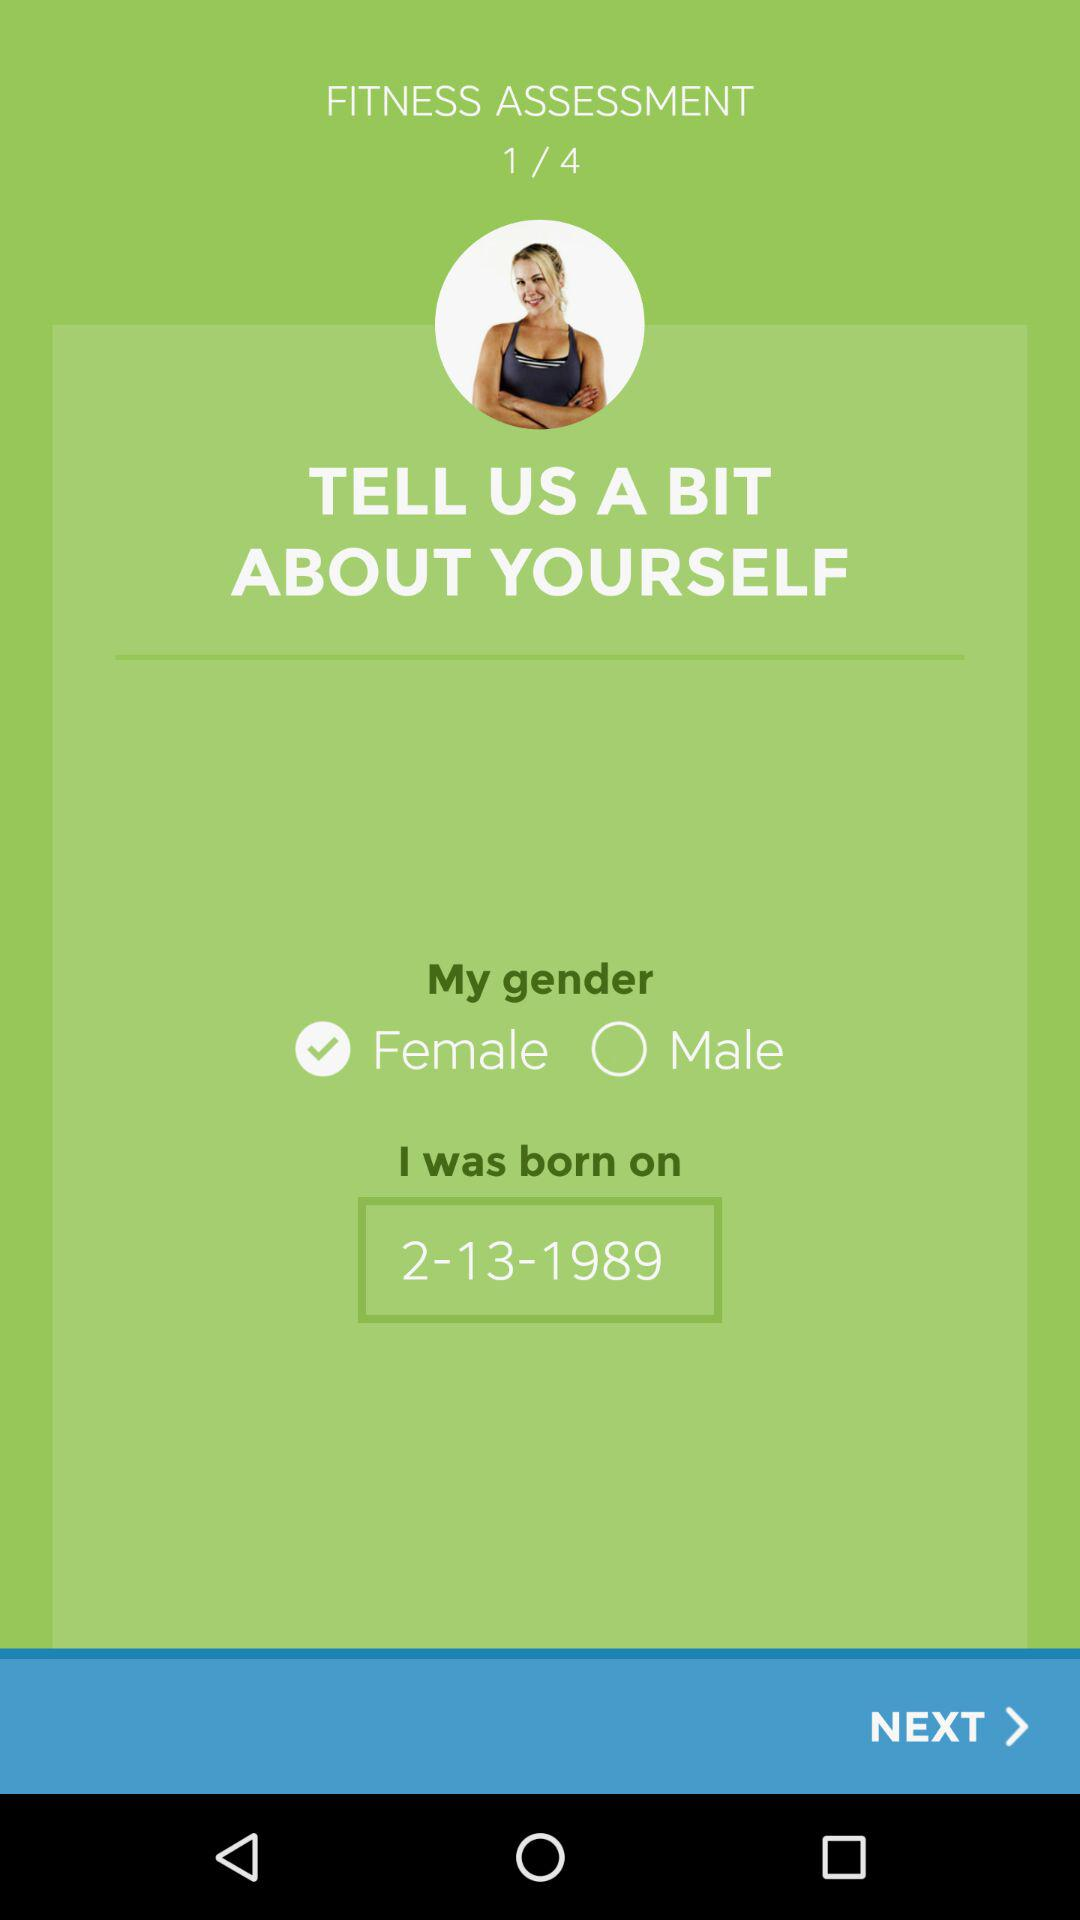What is the date of birth? The date of birth is February 13, 1989. 